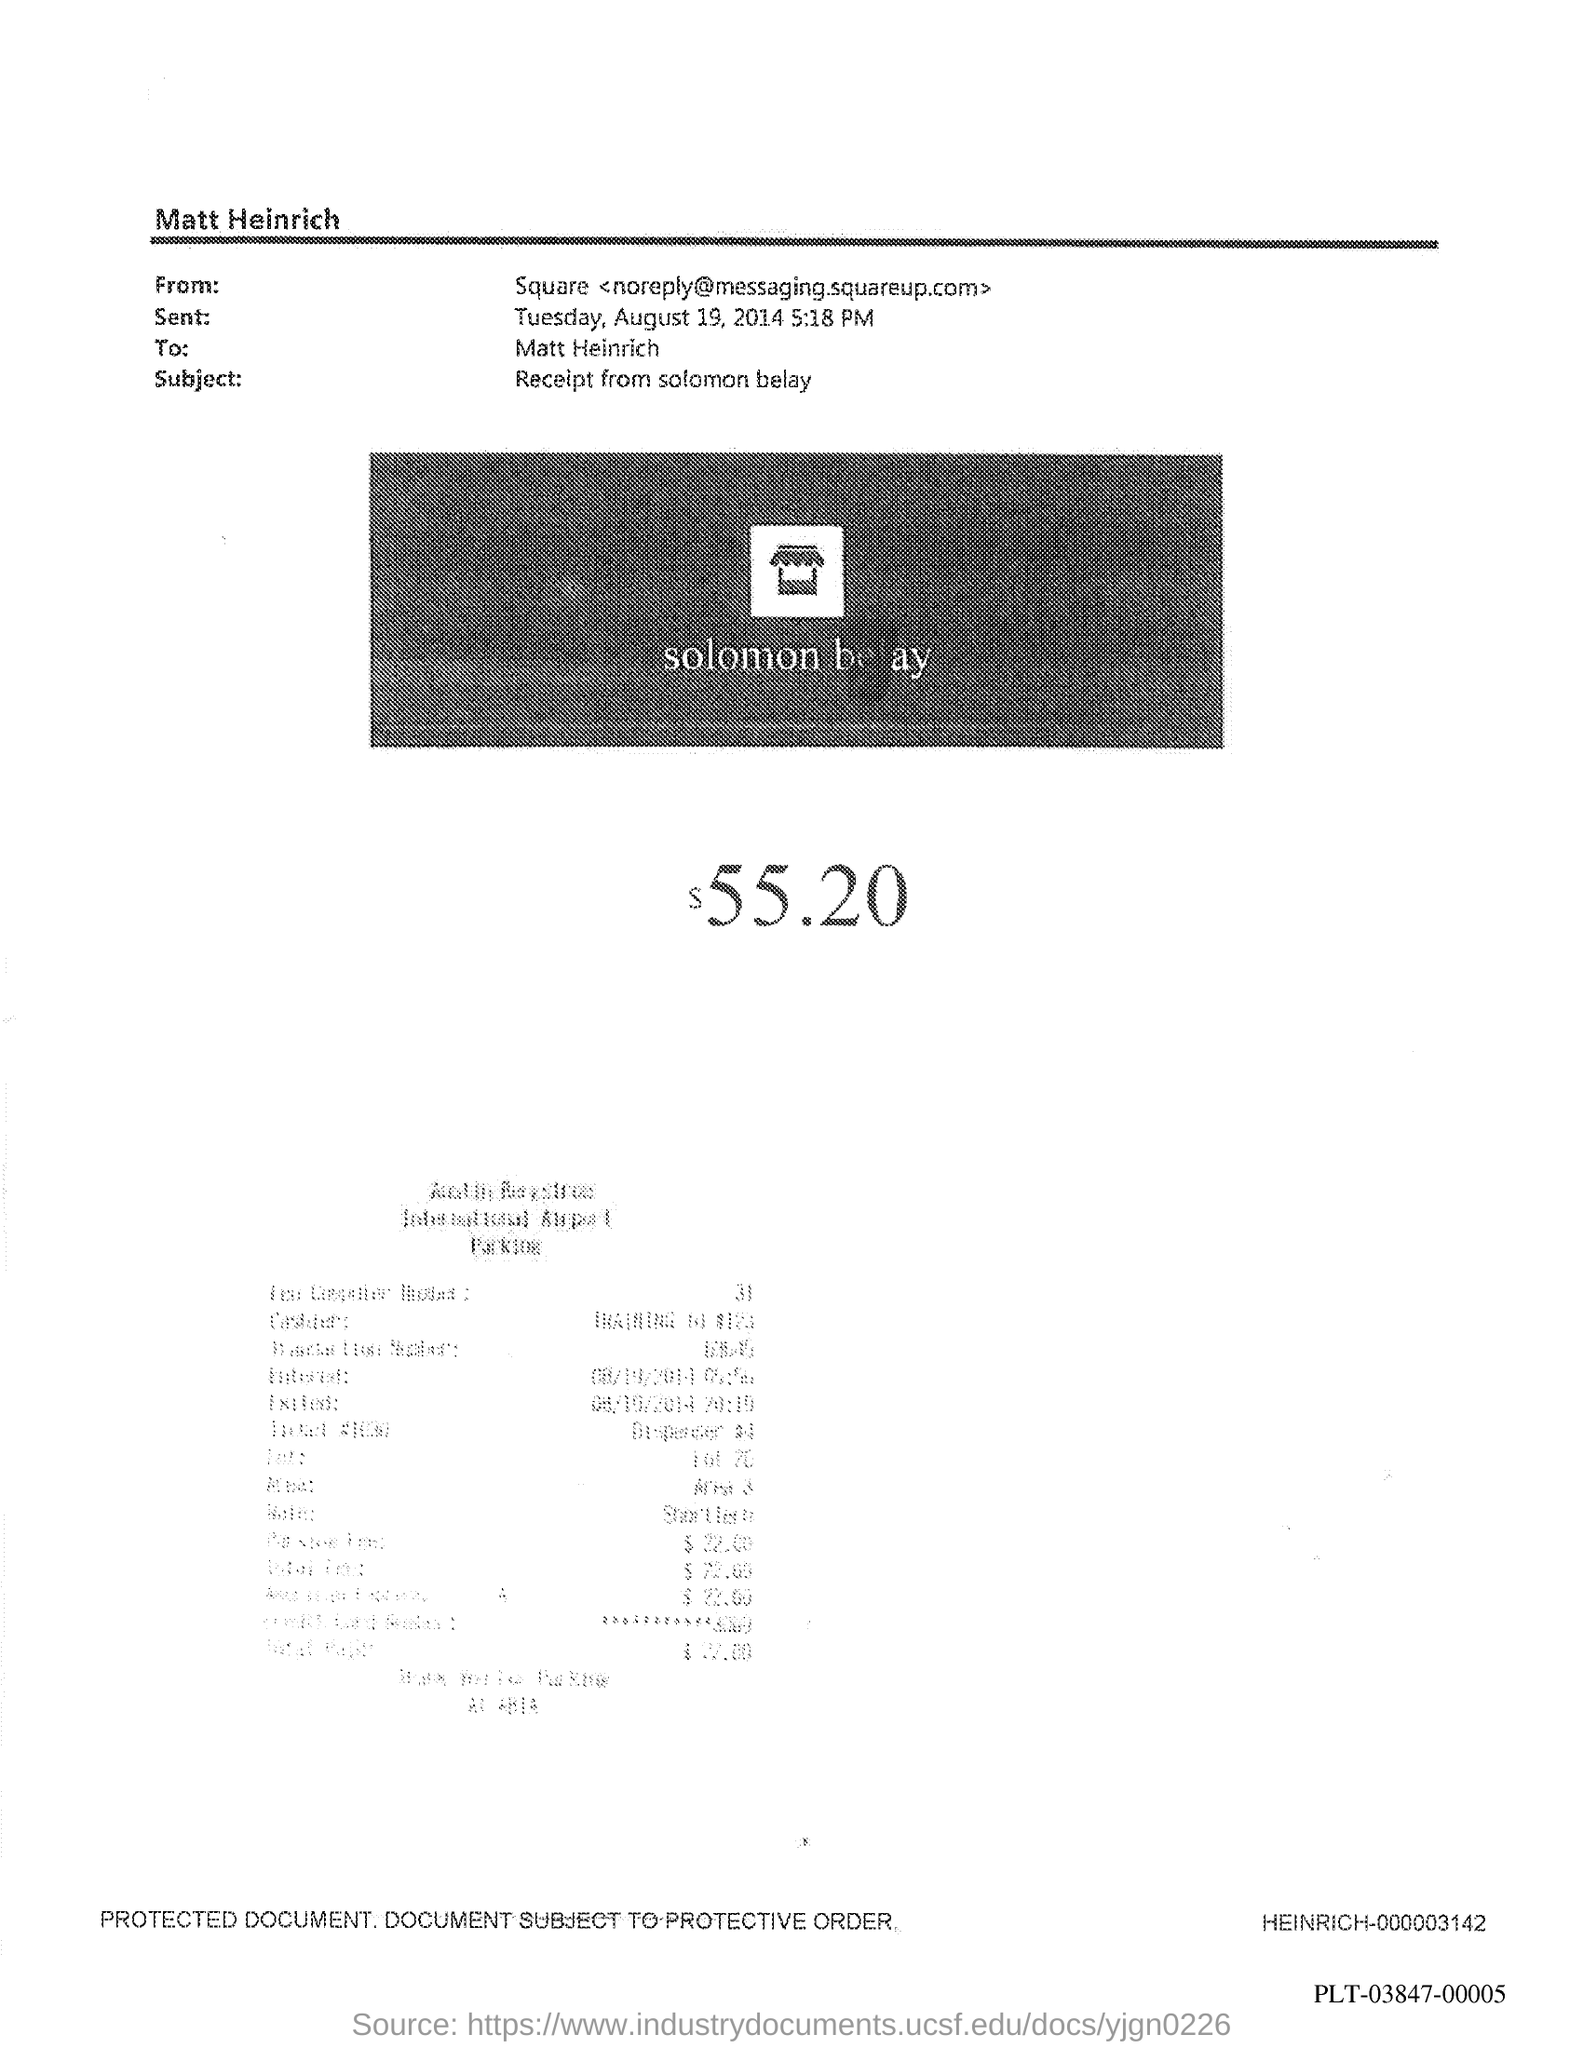What is the subject in the document?
Provide a short and direct response. Receipt from solomon belay. 